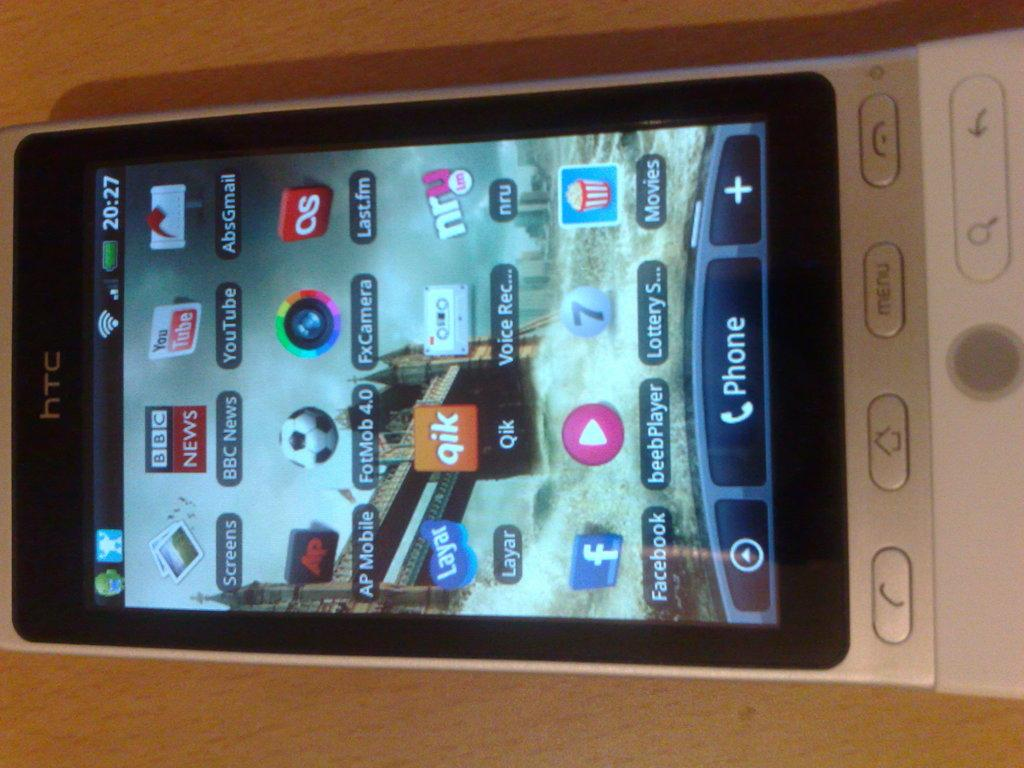<image>
Describe the image concisely. A HTC cellphone with its screen on is laying side ways on a wooden table. 